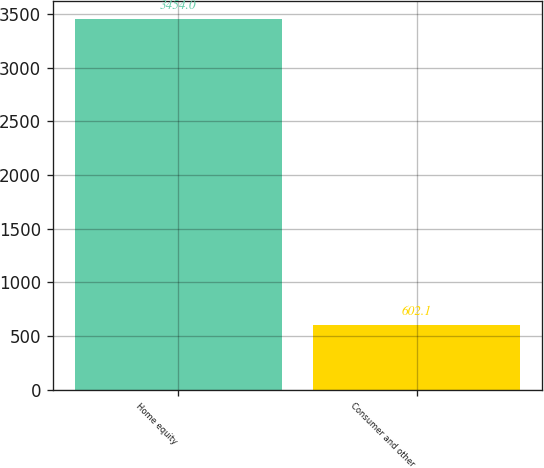<chart> <loc_0><loc_0><loc_500><loc_500><bar_chart><fcel>Home equity<fcel>Consumer and other<nl><fcel>3454<fcel>602.1<nl></chart> 